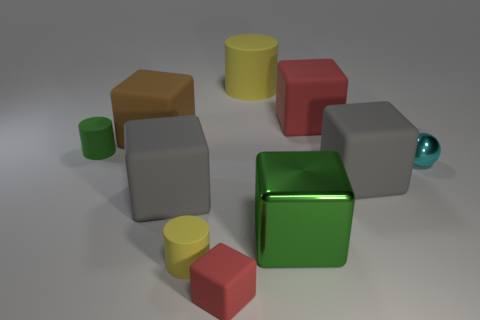How many tiny objects are rubber cylinders or objects?
Ensure brevity in your answer.  4. Are there any other things that are the same color as the small rubber cube?
Your answer should be very brief. Yes. Do the yellow matte cylinder in front of the cyan thing and the big green thing have the same size?
Your answer should be very brief. No. What is the color of the tiny cylinder that is behind the matte cylinder that is in front of the tiny cylinder that is behind the tiny metal object?
Keep it short and to the point. Green. What is the color of the sphere?
Offer a very short reply. Cyan. Does the green thing that is left of the small red matte block have the same material as the small yellow thing on the left side of the tiny red rubber block?
Provide a succinct answer. Yes. There is a green object that is the same shape as the large red matte thing; what is its material?
Provide a succinct answer. Metal. Is the large brown thing made of the same material as the tiny red object?
Offer a very short reply. Yes. The large metal cube that is right of the green thing that is left of the shiny cube is what color?
Ensure brevity in your answer.  Green. What is the size of the ball that is made of the same material as the green cube?
Make the answer very short. Small. 